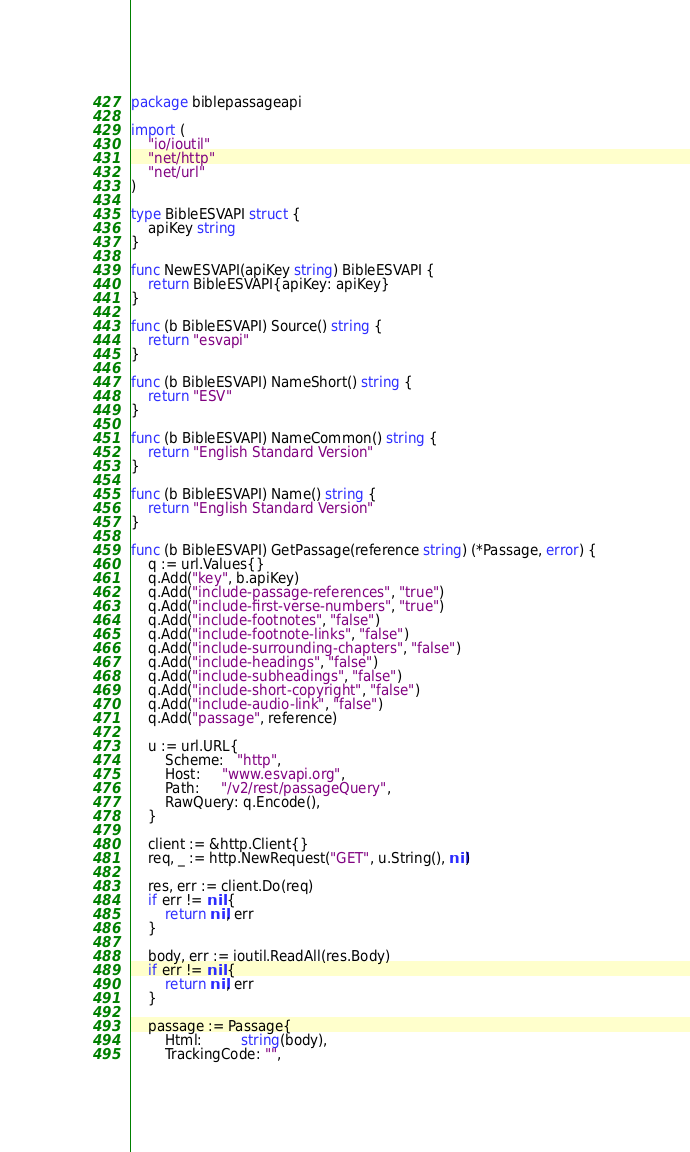<code> <loc_0><loc_0><loc_500><loc_500><_Go_>package biblepassageapi

import (
	"io/ioutil"
	"net/http"
	"net/url"
)

type BibleESVAPI struct {
	apiKey string
}

func NewESVAPI(apiKey string) BibleESVAPI {
	return BibleESVAPI{apiKey: apiKey}
}

func (b BibleESVAPI) Source() string {
	return "esvapi"
}

func (b BibleESVAPI) NameShort() string {
	return "ESV"
}

func (b BibleESVAPI) NameCommon() string {
	return "English Standard Version"
}

func (b BibleESVAPI) Name() string {
	return "English Standard Version"
}

func (b BibleESVAPI) GetPassage(reference string) (*Passage, error) {
	q := url.Values{}
	q.Add("key", b.apiKey)
	q.Add("include-passage-references", "true")
	q.Add("include-first-verse-numbers", "true")
	q.Add("include-footnotes", "false")
	q.Add("include-footnote-links", "false")
	q.Add("include-surrounding-chapters", "false")
	q.Add("include-headings", "false")
	q.Add("include-subheadings", "false")
	q.Add("include-short-copyright", "false")
	q.Add("include-audio-link", "false")
	q.Add("passage", reference)

	u := url.URL{
		Scheme:   "http",
		Host:     "www.esvapi.org",
		Path:     "/v2/rest/passageQuery",
		RawQuery: q.Encode(),
	}

	client := &http.Client{}
	req, _ := http.NewRequest("GET", u.String(), nil)

	res, err := client.Do(req)
	if err != nil {
		return nil, err
	}

	body, err := ioutil.ReadAll(res.Body)
	if err != nil {
		return nil, err
	}

	passage := Passage{
		Html:         string(body),
		TrackingCode: "",</code> 